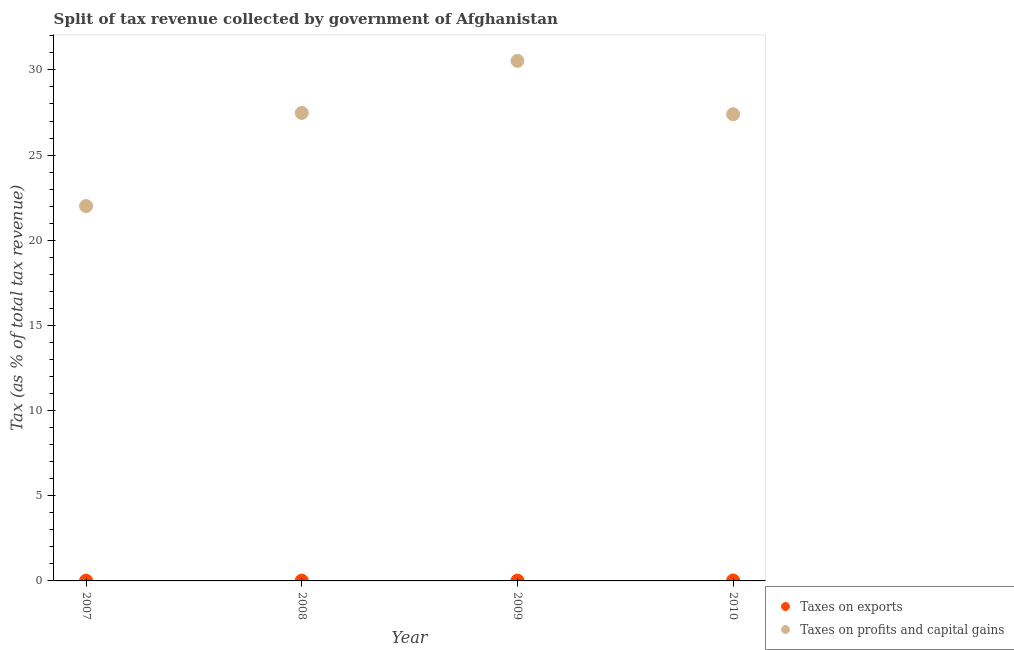Is the number of dotlines equal to the number of legend labels?
Your answer should be compact. Yes. What is the percentage of revenue obtained from taxes on exports in 2008?
Your answer should be very brief. 0.02. Across all years, what is the maximum percentage of revenue obtained from taxes on exports?
Provide a short and direct response. 0.03. Across all years, what is the minimum percentage of revenue obtained from taxes on exports?
Your answer should be compact. 0.01. What is the total percentage of revenue obtained from taxes on exports in the graph?
Your answer should be compact. 0.08. What is the difference between the percentage of revenue obtained from taxes on exports in 2008 and that in 2010?
Keep it short and to the point. -0.01. What is the difference between the percentage of revenue obtained from taxes on profits and capital gains in 2010 and the percentage of revenue obtained from taxes on exports in 2008?
Make the answer very short. 27.38. What is the average percentage of revenue obtained from taxes on exports per year?
Make the answer very short. 0.02. In the year 2007, what is the difference between the percentage of revenue obtained from taxes on exports and percentage of revenue obtained from taxes on profits and capital gains?
Your response must be concise. -22. What is the ratio of the percentage of revenue obtained from taxes on exports in 2008 to that in 2010?
Your response must be concise. 0.66. What is the difference between the highest and the second highest percentage of revenue obtained from taxes on exports?
Offer a terse response. 0.01. What is the difference between the highest and the lowest percentage of revenue obtained from taxes on profits and capital gains?
Your answer should be very brief. 8.52. Is the percentage of revenue obtained from taxes on profits and capital gains strictly greater than the percentage of revenue obtained from taxes on exports over the years?
Keep it short and to the point. Yes. How many dotlines are there?
Ensure brevity in your answer.  2. How many years are there in the graph?
Your response must be concise. 4. Does the graph contain any zero values?
Your answer should be very brief. No. Does the graph contain grids?
Give a very brief answer. No. Where does the legend appear in the graph?
Provide a succinct answer. Bottom right. How many legend labels are there?
Provide a succinct answer. 2. How are the legend labels stacked?
Your response must be concise. Vertical. What is the title of the graph?
Your answer should be very brief. Split of tax revenue collected by government of Afghanistan. Does "Merchandise exports" appear as one of the legend labels in the graph?
Offer a terse response. No. What is the label or title of the Y-axis?
Provide a short and direct response. Tax (as % of total tax revenue). What is the Tax (as % of total tax revenue) of Taxes on exports in 2007?
Offer a very short reply. 0.01. What is the Tax (as % of total tax revenue) in Taxes on profits and capital gains in 2007?
Provide a succinct answer. 22.01. What is the Tax (as % of total tax revenue) in Taxes on exports in 2008?
Your answer should be compact. 0.02. What is the Tax (as % of total tax revenue) in Taxes on profits and capital gains in 2008?
Your answer should be very brief. 27.48. What is the Tax (as % of total tax revenue) of Taxes on exports in 2009?
Give a very brief answer. 0.02. What is the Tax (as % of total tax revenue) in Taxes on profits and capital gains in 2009?
Offer a terse response. 30.53. What is the Tax (as % of total tax revenue) of Taxes on exports in 2010?
Keep it short and to the point. 0.03. What is the Tax (as % of total tax revenue) of Taxes on profits and capital gains in 2010?
Keep it short and to the point. 27.4. Across all years, what is the maximum Tax (as % of total tax revenue) of Taxes on exports?
Keep it short and to the point. 0.03. Across all years, what is the maximum Tax (as % of total tax revenue) of Taxes on profits and capital gains?
Your answer should be compact. 30.53. Across all years, what is the minimum Tax (as % of total tax revenue) in Taxes on exports?
Offer a terse response. 0.01. Across all years, what is the minimum Tax (as % of total tax revenue) in Taxes on profits and capital gains?
Give a very brief answer. 22.01. What is the total Tax (as % of total tax revenue) of Taxes on exports in the graph?
Give a very brief answer. 0.08. What is the total Tax (as % of total tax revenue) in Taxes on profits and capital gains in the graph?
Your answer should be compact. 107.41. What is the difference between the Tax (as % of total tax revenue) of Taxes on exports in 2007 and that in 2008?
Offer a terse response. -0.01. What is the difference between the Tax (as % of total tax revenue) of Taxes on profits and capital gains in 2007 and that in 2008?
Offer a very short reply. -5.47. What is the difference between the Tax (as % of total tax revenue) in Taxes on exports in 2007 and that in 2009?
Make the answer very short. -0. What is the difference between the Tax (as % of total tax revenue) in Taxes on profits and capital gains in 2007 and that in 2009?
Keep it short and to the point. -8.52. What is the difference between the Tax (as % of total tax revenue) of Taxes on exports in 2007 and that in 2010?
Give a very brief answer. -0.02. What is the difference between the Tax (as % of total tax revenue) in Taxes on profits and capital gains in 2007 and that in 2010?
Your answer should be very brief. -5.39. What is the difference between the Tax (as % of total tax revenue) of Taxes on exports in 2008 and that in 2009?
Offer a terse response. 0. What is the difference between the Tax (as % of total tax revenue) in Taxes on profits and capital gains in 2008 and that in 2009?
Provide a short and direct response. -3.06. What is the difference between the Tax (as % of total tax revenue) of Taxes on exports in 2008 and that in 2010?
Keep it short and to the point. -0.01. What is the difference between the Tax (as % of total tax revenue) of Taxes on profits and capital gains in 2008 and that in 2010?
Give a very brief answer. 0.08. What is the difference between the Tax (as % of total tax revenue) in Taxes on exports in 2009 and that in 2010?
Your answer should be compact. -0.01. What is the difference between the Tax (as % of total tax revenue) of Taxes on profits and capital gains in 2009 and that in 2010?
Your answer should be very brief. 3.13. What is the difference between the Tax (as % of total tax revenue) in Taxes on exports in 2007 and the Tax (as % of total tax revenue) in Taxes on profits and capital gains in 2008?
Ensure brevity in your answer.  -27.46. What is the difference between the Tax (as % of total tax revenue) in Taxes on exports in 2007 and the Tax (as % of total tax revenue) in Taxes on profits and capital gains in 2009?
Offer a very short reply. -30.52. What is the difference between the Tax (as % of total tax revenue) of Taxes on exports in 2007 and the Tax (as % of total tax revenue) of Taxes on profits and capital gains in 2010?
Your answer should be very brief. -27.38. What is the difference between the Tax (as % of total tax revenue) in Taxes on exports in 2008 and the Tax (as % of total tax revenue) in Taxes on profits and capital gains in 2009?
Offer a terse response. -30.51. What is the difference between the Tax (as % of total tax revenue) in Taxes on exports in 2008 and the Tax (as % of total tax revenue) in Taxes on profits and capital gains in 2010?
Give a very brief answer. -27.38. What is the difference between the Tax (as % of total tax revenue) of Taxes on exports in 2009 and the Tax (as % of total tax revenue) of Taxes on profits and capital gains in 2010?
Your answer should be compact. -27.38. What is the average Tax (as % of total tax revenue) of Taxes on profits and capital gains per year?
Ensure brevity in your answer.  26.85. In the year 2007, what is the difference between the Tax (as % of total tax revenue) of Taxes on exports and Tax (as % of total tax revenue) of Taxes on profits and capital gains?
Keep it short and to the point. -22. In the year 2008, what is the difference between the Tax (as % of total tax revenue) in Taxes on exports and Tax (as % of total tax revenue) in Taxes on profits and capital gains?
Offer a very short reply. -27.46. In the year 2009, what is the difference between the Tax (as % of total tax revenue) of Taxes on exports and Tax (as % of total tax revenue) of Taxes on profits and capital gains?
Offer a very short reply. -30.51. In the year 2010, what is the difference between the Tax (as % of total tax revenue) in Taxes on exports and Tax (as % of total tax revenue) in Taxes on profits and capital gains?
Make the answer very short. -27.37. What is the ratio of the Tax (as % of total tax revenue) in Taxes on exports in 2007 to that in 2008?
Your response must be concise. 0.7. What is the ratio of the Tax (as % of total tax revenue) of Taxes on profits and capital gains in 2007 to that in 2008?
Make the answer very short. 0.8. What is the ratio of the Tax (as % of total tax revenue) in Taxes on exports in 2007 to that in 2009?
Offer a very short reply. 0.79. What is the ratio of the Tax (as % of total tax revenue) in Taxes on profits and capital gains in 2007 to that in 2009?
Provide a short and direct response. 0.72. What is the ratio of the Tax (as % of total tax revenue) of Taxes on exports in 2007 to that in 2010?
Make the answer very short. 0.46. What is the ratio of the Tax (as % of total tax revenue) in Taxes on profits and capital gains in 2007 to that in 2010?
Provide a succinct answer. 0.8. What is the ratio of the Tax (as % of total tax revenue) in Taxes on exports in 2008 to that in 2009?
Provide a short and direct response. 1.12. What is the ratio of the Tax (as % of total tax revenue) in Taxes on profits and capital gains in 2008 to that in 2009?
Your answer should be very brief. 0.9. What is the ratio of the Tax (as % of total tax revenue) of Taxes on exports in 2008 to that in 2010?
Offer a terse response. 0.66. What is the ratio of the Tax (as % of total tax revenue) of Taxes on exports in 2009 to that in 2010?
Provide a succinct answer. 0.59. What is the ratio of the Tax (as % of total tax revenue) in Taxes on profits and capital gains in 2009 to that in 2010?
Give a very brief answer. 1.11. What is the difference between the highest and the second highest Tax (as % of total tax revenue) of Taxes on exports?
Your answer should be very brief. 0.01. What is the difference between the highest and the second highest Tax (as % of total tax revenue) in Taxes on profits and capital gains?
Give a very brief answer. 3.06. What is the difference between the highest and the lowest Tax (as % of total tax revenue) in Taxes on exports?
Give a very brief answer. 0.02. What is the difference between the highest and the lowest Tax (as % of total tax revenue) of Taxes on profits and capital gains?
Provide a succinct answer. 8.52. 